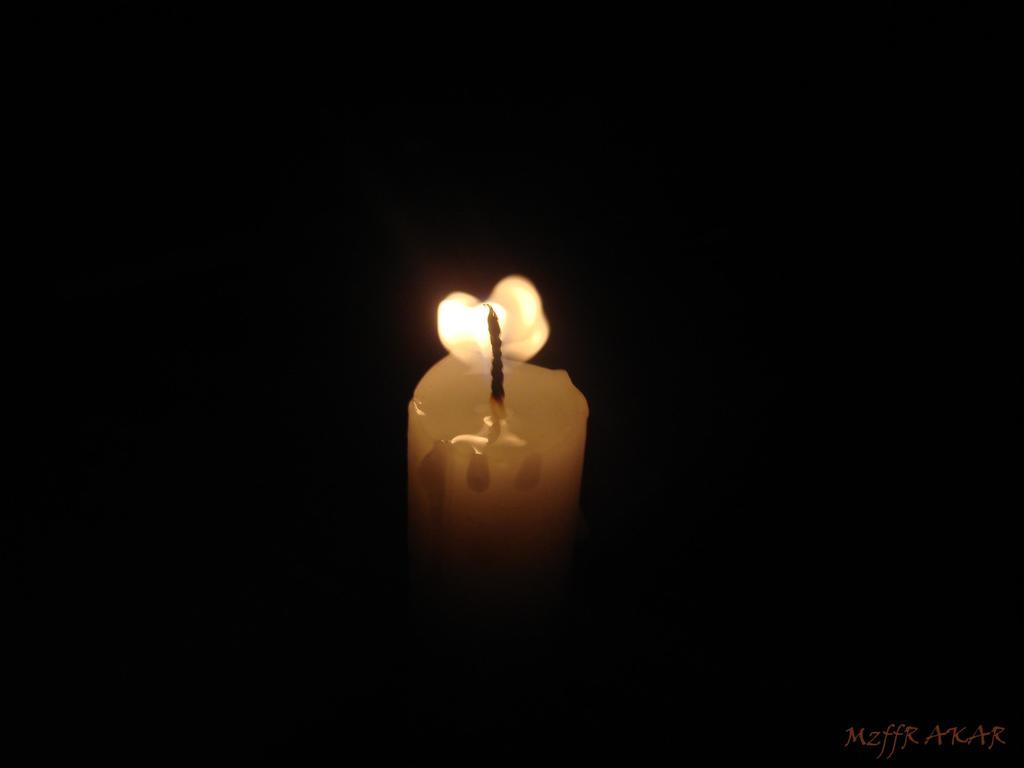What object is the main focus of the image? There is a candle in the image. How would you describe the overall lighting in the image? The background of the image is dark. Is there any text present in the image? Yes, there is some text at the bottom right corner of the image. What type of boot is shown next to the candle in the image? There is no boot present in the image; it only features a candle and some text. What belief system is represented by the candle in the image? The image does not indicate any specific belief system associated with the candle. 